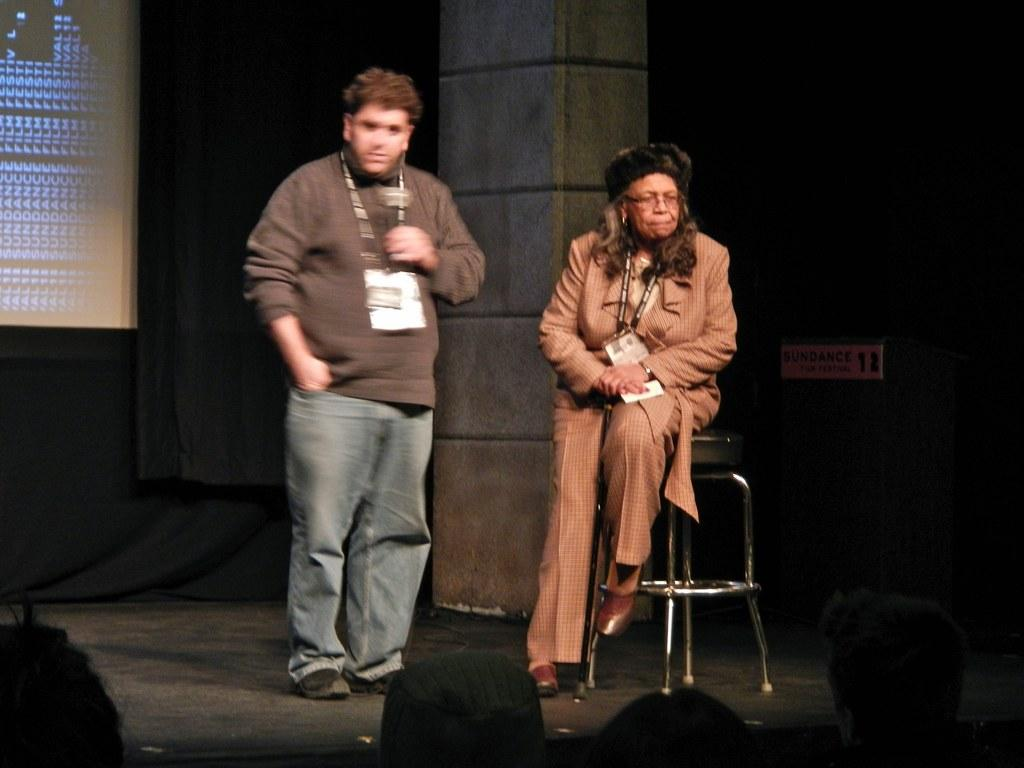What is the position of the person on the left side of the image? There is a person standing on the left side of the image. What is the position of the other person in the image? There is a person sitting on a table in the image. What type of structure can be seen in the image? There is a pillar visible in the image. How does the person sitting on the table test the strength of the pillar in the image? There is no indication in the image that the person sitting on the table is testing the strength of the pillar. 